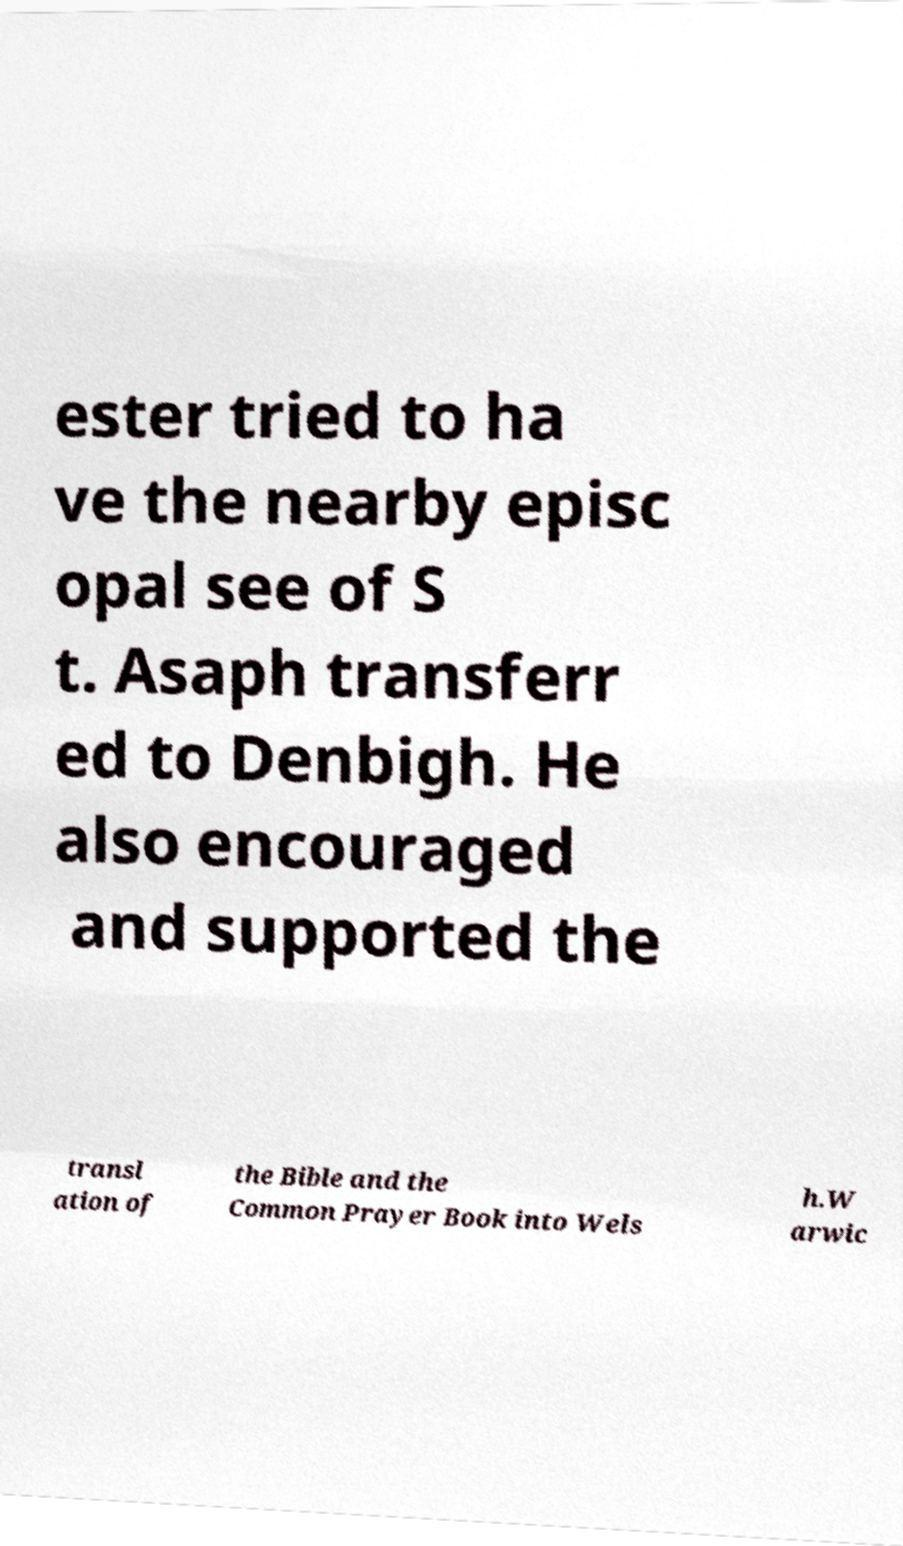Can you accurately transcribe the text from the provided image for me? ester tried to ha ve the nearby episc opal see of S t. Asaph transferr ed to Denbigh. He also encouraged and supported the transl ation of the Bible and the Common Prayer Book into Wels h.W arwic 